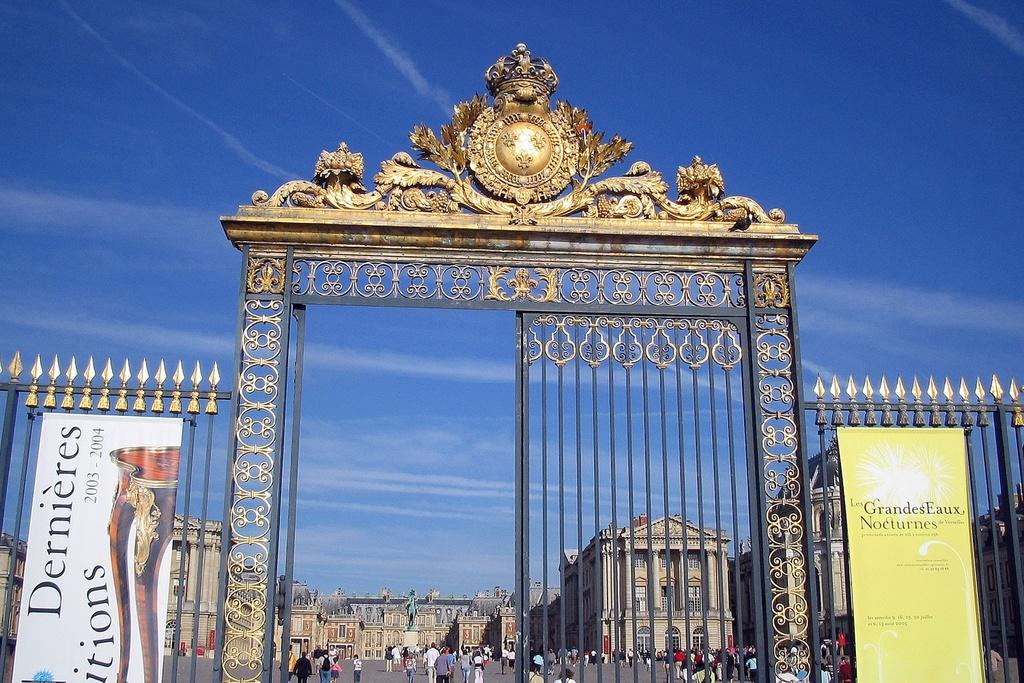What is the main structure in the center of the image? There is a gate in the center of the image. What can be seen at the top of the image? The sky is visible at the top of the image. What type of structures are visible in the background of the image? There are buildings in the background of the image. Are there any people present in the image? Yes, there are people on the road. How do the nerves of the people on the road affect their ability to measure the distance between the buildings? There is no mention of measuring distances or nerves in the image, so this question cannot be answered definitively. 